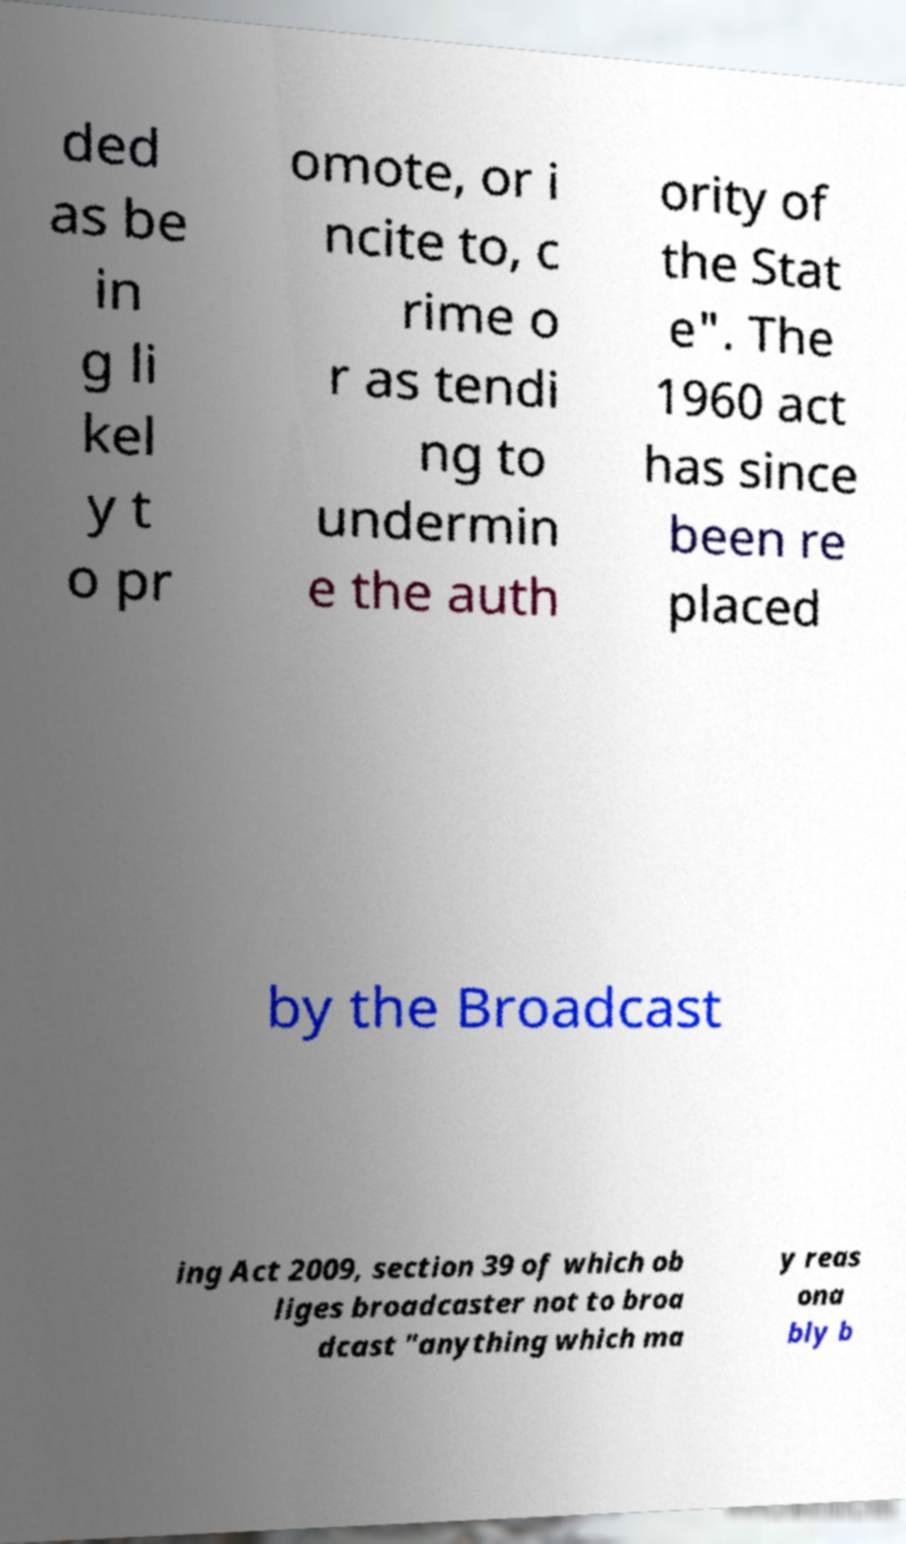Could you extract and type out the text from this image? ded as be in g li kel y t o pr omote, or i ncite to, c rime o r as tendi ng to undermin e the auth ority of the Stat e". The 1960 act has since been re placed by the Broadcast ing Act 2009, section 39 of which ob liges broadcaster not to broa dcast "anything which ma y reas ona bly b 